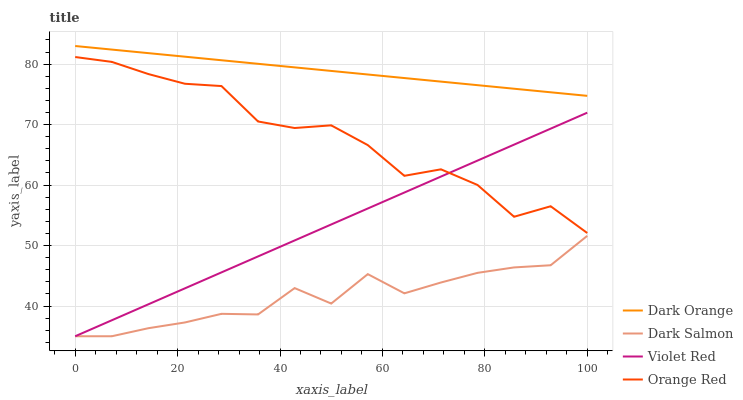Does Violet Red have the minimum area under the curve?
Answer yes or no. No. Does Violet Red have the maximum area under the curve?
Answer yes or no. No. Is Violet Red the smoothest?
Answer yes or no. No. Is Violet Red the roughest?
Answer yes or no. No. Does Orange Red have the lowest value?
Answer yes or no. No. Does Violet Red have the highest value?
Answer yes or no. No. Is Dark Salmon less than Dark Orange?
Answer yes or no. Yes. Is Dark Orange greater than Orange Red?
Answer yes or no. Yes. Does Dark Salmon intersect Dark Orange?
Answer yes or no. No. 